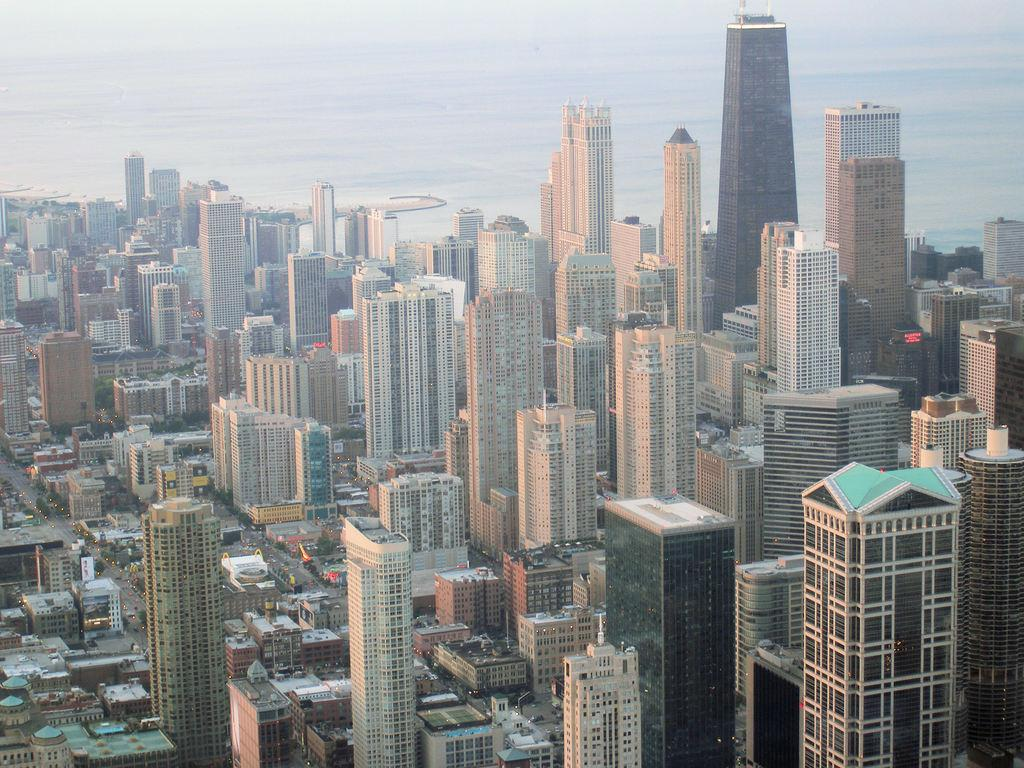Where was the image taken? The image was clicked outside the city. What type of structures can be seen in the image? There are many buildings in the image. How is the image taken? The image is a top view. What can be seen in the background of the image? The sky is visible in the background of the image. What type of pleasure can be seen in the image? There is no indication of pleasure in the image; it primarily features buildings and the sky. Can you see the father in the image? There is no person, including a father, present in the image. 